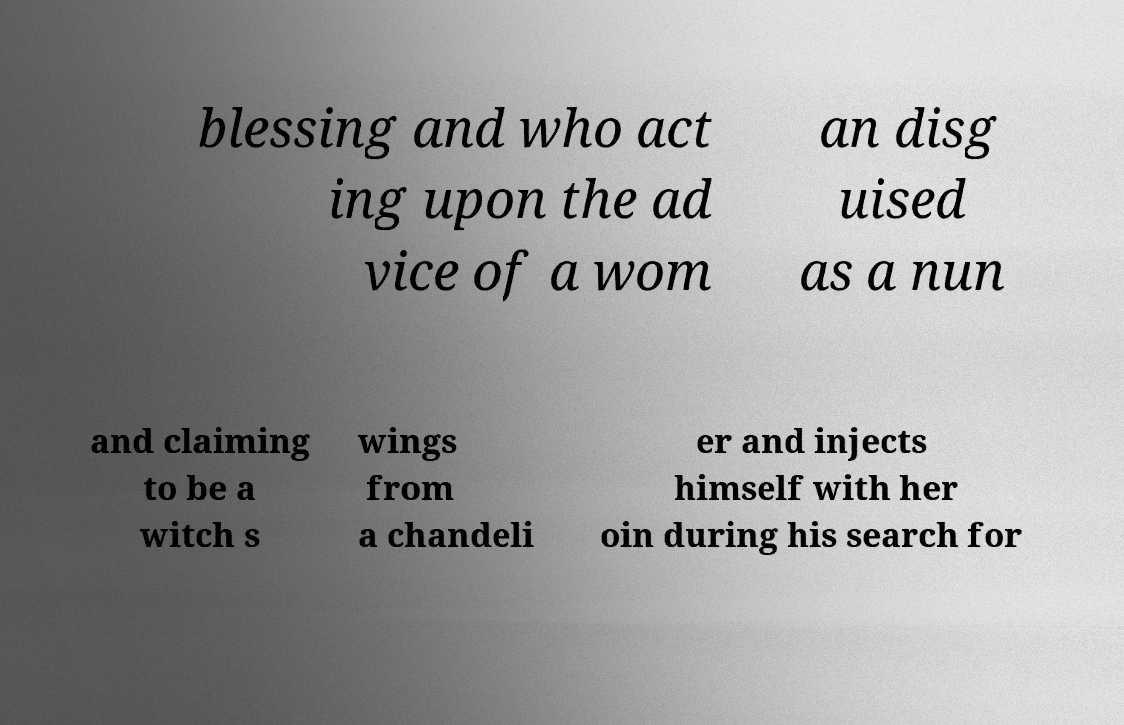I need the written content from this picture converted into text. Can you do that? blessing and who act ing upon the ad vice of a wom an disg uised as a nun and claiming to be a witch s wings from a chandeli er and injects himself with her oin during his search for 